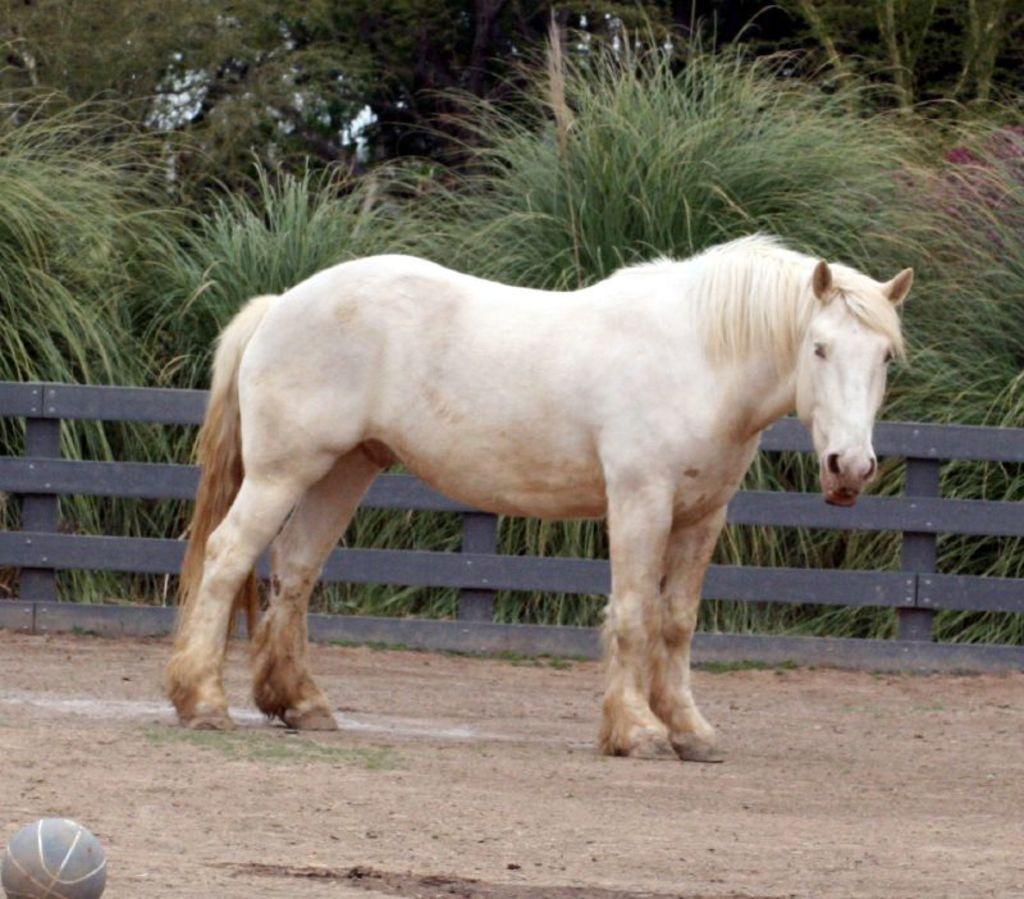Can you describe this image briefly? In this image I can see a white horse standing on the ground. In the background I can see fence, plants and trees. Here I can see a ball on the ground. 